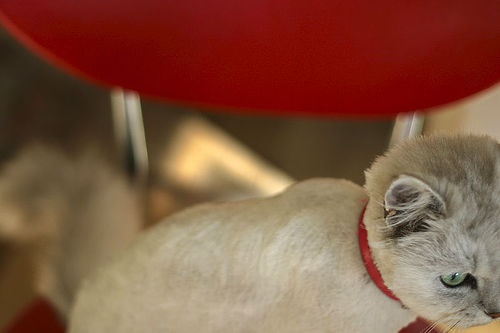Describe the objects in this image and their specific colors. I can see cat in maroon, tan, and gray tones and chair in maroon and gray tones in this image. 